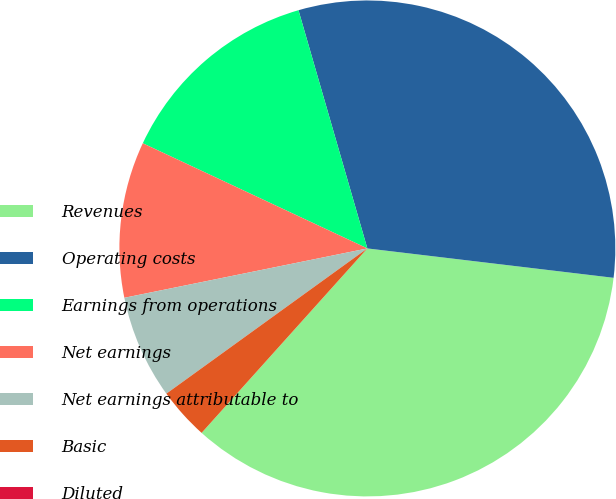Convert chart to OTSL. <chart><loc_0><loc_0><loc_500><loc_500><pie_chart><fcel>Revenues<fcel>Operating costs<fcel>Earnings from operations<fcel>Net earnings<fcel>Net earnings attributable to<fcel>Basic<fcel>Diluted<nl><fcel>34.76%<fcel>31.37%<fcel>13.55%<fcel>10.16%<fcel>6.77%<fcel>3.39%<fcel>0.0%<nl></chart> 